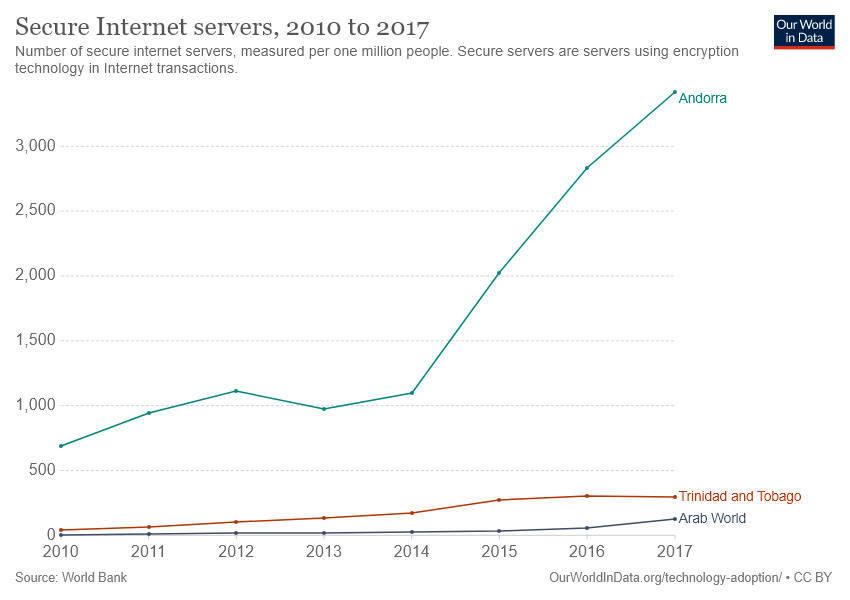List a handful of essential elements in this visual. In 2017, the Arab World had the fewest secure internet servers out of all regions surveyed. In 2017, the number of secure internet servers in the Arab World and Trinidad and Tobago was not greater than the number in Andorra. 